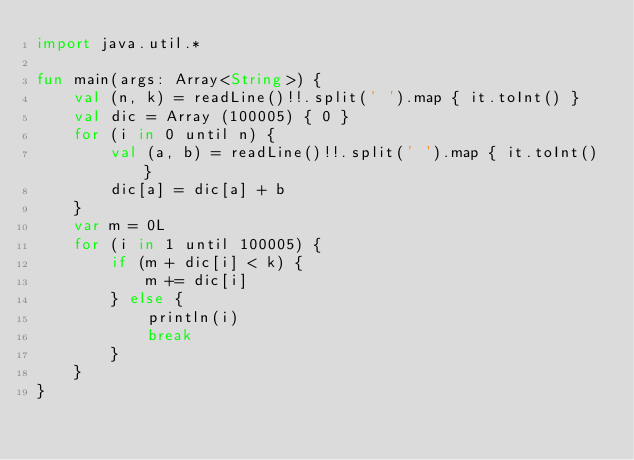<code> <loc_0><loc_0><loc_500><loc_500><_Kotlin_>import java.util.*

fun main(args: Array<String>) {
    val (n, k) = readLine()!!.split(' ').map { it.toInt() }
    val dic = Array (100005) { 0 }
    for (i in 0 until n) {
        val (a, b) = readLine()!!.split(' ').map { it.toInt() }
        dic[a] = dic[a] + b
    }
    var m = 0L
    for (i in 1 until 100005) {
        if (m + dic[i] < k) {
            m += dic[i]
        } else {
            println(i)
            break
        }
    }
}</code> 